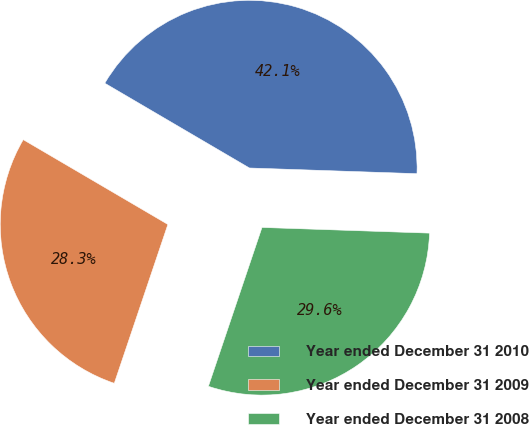<chart> <loc_0><loc_0><loc_500><loc_500><pie_chart><fcel>Year ended December 31 2010<fcel>Year ended December 31 2009<fcel>Year ended December 31 2008<nl><fcel>42.1%<fcel>28.26%<fcel>29.64%<nl></chart> 